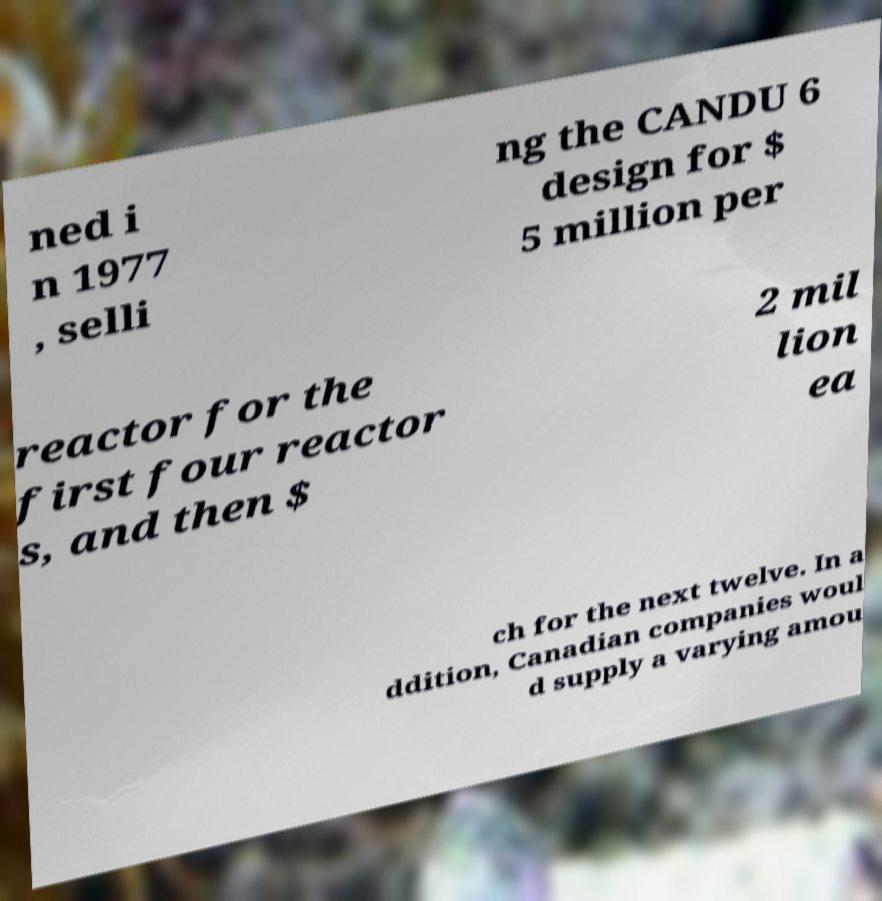Can you read and provide the text displayed in the image?This photo seems to have some interesting text. Can you extract and type it out for me? ned i n 1977 , selli ng the CANDU 6 design for $ 5 million per reactor for the first four reactor s, and then $ 2 mil lion ea ch for the next twelve. In a ddition, Canadian companies woul d supply a varying amou 